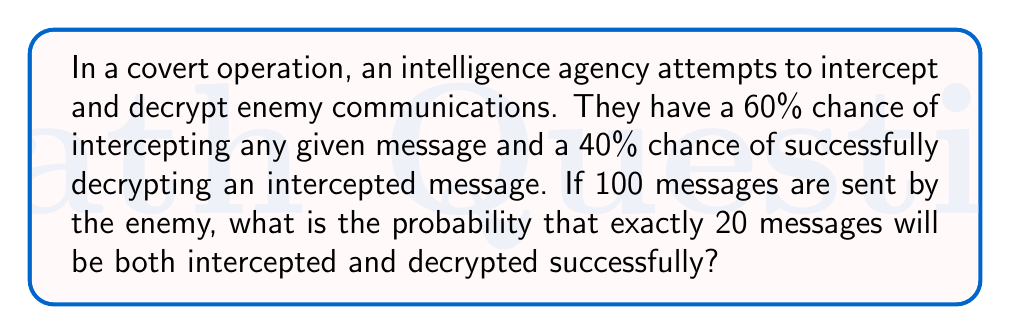Give your solution to this math problem. To solve this problem, we need to use the binomial probability distribution. Let's break it down step-by-step:

1) First, we need to calculate the probability of successfully intercepting and decrypting a single message:
   $P(\text{intercept and decrypt}) = P(\text{intercept}) \times P(\text{decrypt | intercept})$
   $= 0.60 \times 0.40 = 0.24$

2) Now, we can use the binomial probability formula:
   $P(X = k) = \binom{n}{k} p^k (1-p)^{n-k}$
   
   Where:
   $n = 100$ (total number of messages)
   $k = 20$ (number of successful interceptions and decryptions)
   $p = 0.24$ (probability of success for a single message)

3) Let's substitute these values:
   $P(X = 20) = \binom{100}{20} (0.24)^{20} (1-0.24)^{100-20}$

4) Simplify:
   $P(X = 20) = \binom{100}{20} (0.24)^{20} (0.76)^{80}$

5) Calculate the binomial coefficient:
   $\binom{100}{20} = \frac{100!}{20!(100-20)!} = \frac{100!}{20!80!} \approx 5.36 \times 10^{20}$

6) Now, let's put it all together:
   $P(X = 20) \approx (5.36 \times 10^{20}) \times (0.24)^{20} \times (0.76)^{80}$

7) Using a calculator or computer (due to the large numbers involved):
   $P(X = 20) \approx 0.0399 \text{ or } 3.99\%$

This means there's about a 3.99% chance that exactly 20 out of 100 messages will be both intercepted and decrypted successfully.
Answer: $0.0399$ or $3.99\%$ 